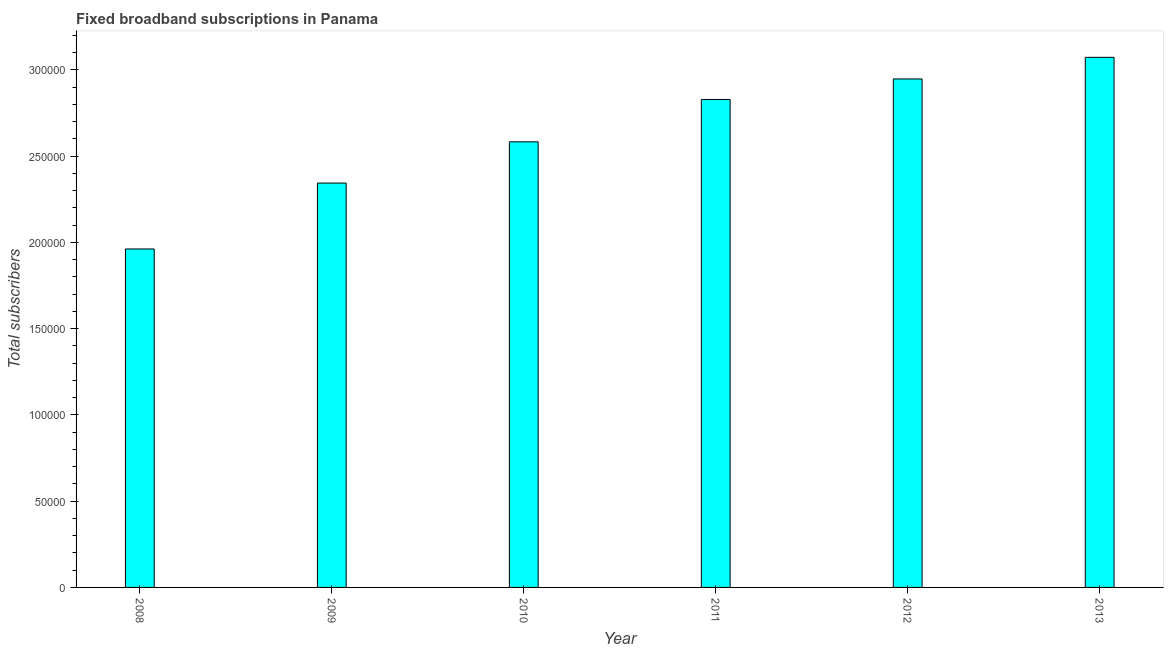Does the graph contain grids?
Your answer should be very brief. No. What is the title of the graph?
Your response must be concise. Fixed broadband subscriptions in Panama. What is the label or title of the Y-axis?
Offer a very short reply. Total subscribers. What is the total number of fixed broadband subscriptions in 2011?
Make the answer very short. 2.83e+05. Across all years, what is the maximum total number of fixed broadband subscriptions?
Provide a succinct answer. 3.07e+05. Across all years, what is the minimum total number of fixed broadband subscriptions?
Give a very brief answer. 1.96e+05. In which year was the total number of fixed broadband subscriptions maximum?
Make the answer very short. 2013. What is the sum of the total number of fixed broadband subscriptions?
Keep it short and to the point. 1.57e+06. What is the difference between the total number of fixed broadband subscriptions in 2008 and 2011?
Your answer should be very brief. -8.67e+04. What is the average total number of fixed broadband subscriptions per year?
Make the answer very short. 2.62e+05. What is the median total number of fixed broadband subscriptions?
Your answer should be compact. 2.71e+05. Do a majority of the years between 2009 and 2013 (inclusive) have total number of fixed broadband subscriptions greater than 190000 ?
Give a very brief answer. Yes. What is the ratio of the total number of fixed broadband subscriptions in 2008 to that in 2013?
Your answer should be very brief. 0.64. Is the total number of fixed broadband subscriptions in 2009 less than that in 2013?
Keep it short and to the point. Yes. What is the difference between the highest and the second highest total number of fixed broadband subscriptions?
Make the answer very short. 1.25e+04. Is the sum of the total number of fixed broadband subscriptions in 2009 and 2012 greater than the maximum total number of fixed broadband subscriptions across all years?
Give a very brief answer. Yes. What is the difference between the highest and the lowest total number of fixed broadband subscriptions?
Your answer should be very brief. 1.11e+05. How many bars are there?
Your answer should be compact. 6. Are all the bars in the graph horizontal?
Make the answer very short. No. What is the Total subscribers of 2008?
Offer a terse response. 1.96e+05. What is the Total subscribers in 2009?
Offer a very short reply. 2.34e+05. What is the Total subscribers of 2010?
Your answer should be very brief. 2.58e+05. What is the Total subscribers in 2011?
Your answer should be compact. 2.83e+05. What is the Total subscribers in 2012?
Make the answer very short. 2.95e+05. What is the Total subscribers of 2013?
Your response must be concise. 3.07e+05. What is the difference between the Total subscribers in 2008 and 2009?
Your answer should be compact. -3.82e+04. What is the difference between the Total subscribers in 2008 and 2010?
Your answer should be compact. -6.21e+04. What is the difference between the Total subscribers in 2008 and 2011?
Provide a short and direct response. -8.67e+04. What is the difference between the Total subscribers in 2008 and 2012?
Your response must be concise. -9.85e+04. What is the difference between the Total subscribers in 2008 and 2013?
Make the answer very short. -1.11e+05. What is the difference between the Total subscribers in 2009 and 2010?
Provide a short and direct response. -2.39e+04. What is the difference between the Total subscribers in 2009 and 2011?
Ensure brevity in your answer.  -4.85e+04. What is the difference between the Total subscribers in 2009 and 2012?
Make the answer very short. -6.04e+04. What is the difference between the Total subscribers in 2009 and 2013?
Offer a very short reply. -7.29e+04. What is the difference between the Total subscribers in 2010 and 2011?
Provide a short and direct response. -2.46e+04. What is the difference between the Total subscribers in 2010 and 2012?
Give a very brief answer. -3.64e+04. What is the difference between the Total subscribers in 2010 and 2013?
Keep it short and to the point. -4.90e+04. What is the difference between the Total subscribers in 2011 and 2012?
Provide a succinct answer. -1.19e+04. What is the difference between the Total subscribers in 2011 and 2013?
Provide a short and direct response. -2.44e+04. What is the difference between the Total subscribers in 2012 and 2013?
Make the answer very short. -1.25e+04. What is the ratio of the Total subscribers in 2008 to that in 2009?
Give a very brief answer. 0.84. What is the ratio of the Total subscribers in 2008 to that in 2010?
Provide a short and direct response. 0.76. What is the ratio of the Total subscribers in 2008 to that in 2011?
Provide a succinct answer. 0.69. What is the ratio of the Total subscribers in 2008 to that in 2012?
Your answer should be compact. 0.67. What is the ratio of the Total subscribers in 2008 to that in 2013?
Offer a very short reply. 0.64. What is the ratio of the Total subscribers in 2009 to that in 2010?
Keep it short and to the point. 0.91. What is the ratio of the Total subscribers in 2009 to that in 2011?
Provide a succinct answer. 0.83. What is the ratio of the Total subscribers in 2009 to that in 2012?
Provide a succinct answer. 0.8. What is the ratio of the Total subscribers in 2009 to that in 2013?
Provide a short and direct response. 0.76. What is the ratio of the Total subscribers in 2010 to that in 2012?
Give a very brief answer. 0.88. What is the ratio of the Total subscribers in 2010 to that in 2013?
Your answer should be very brief. 0.84. What is the ratio of the Total subscribers in 2011 to that in 2013?
Ensure brevity in your answer.  0.92. What is the ratio of the Total subscribers in 2012 to that in 2013?
Provide a short and direct response. 0.96. 